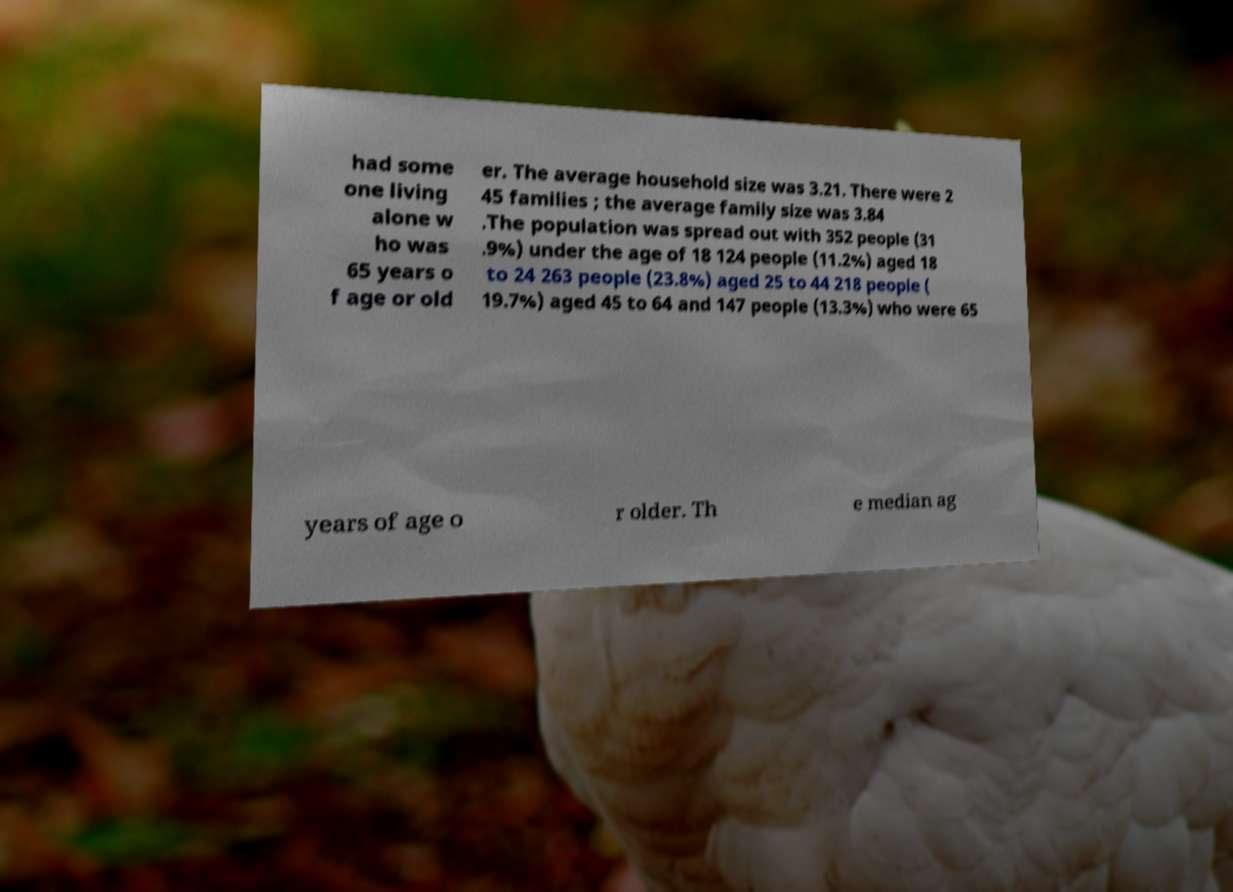Please identify and transcribe the text found in this image. had some one living alone w ho was 65 years o f age or old er. The average household size was 3.21. There were 2 45 families ; the average family size was 3.84 .The population was spread out with 352 people (31 .9%) under the age of 18 124 people (11.2%) aged 18 to 24 263 people (23.8%) aged 25 to 44 218 people ( 19.7%) aged 45 to 64 and 147 people (13.3%) who were 65 years of age o r older. Th e median ag 